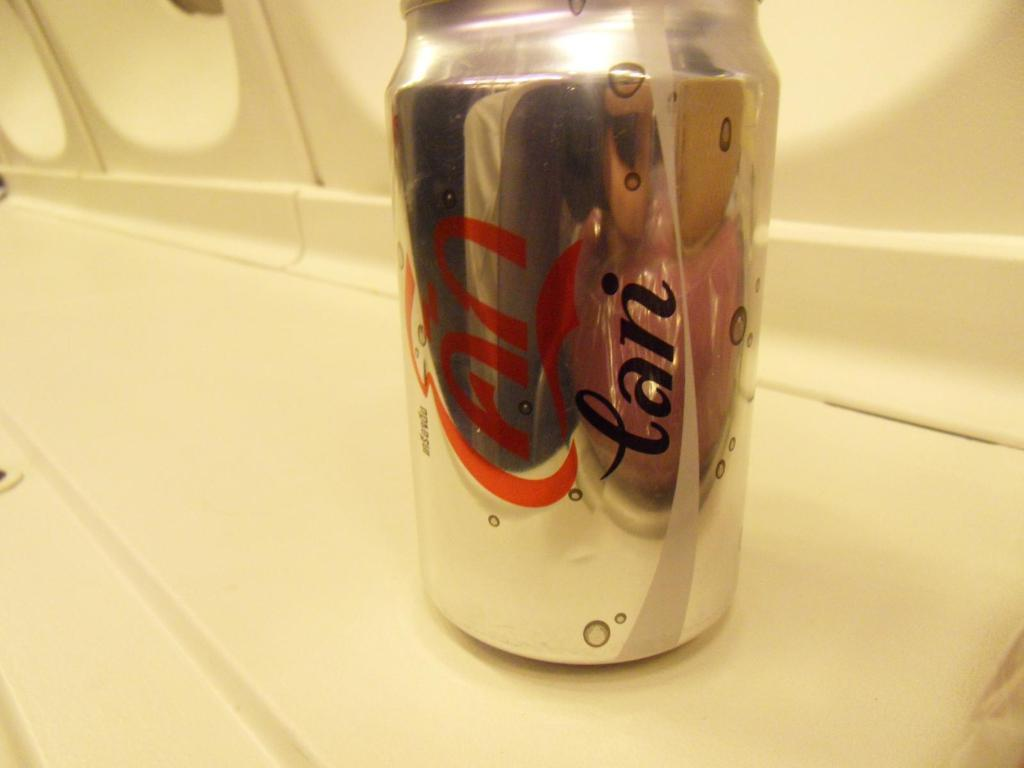Provide a one-sentence caption for the provided image. A can of soda with foreign writing in red and black on it. 